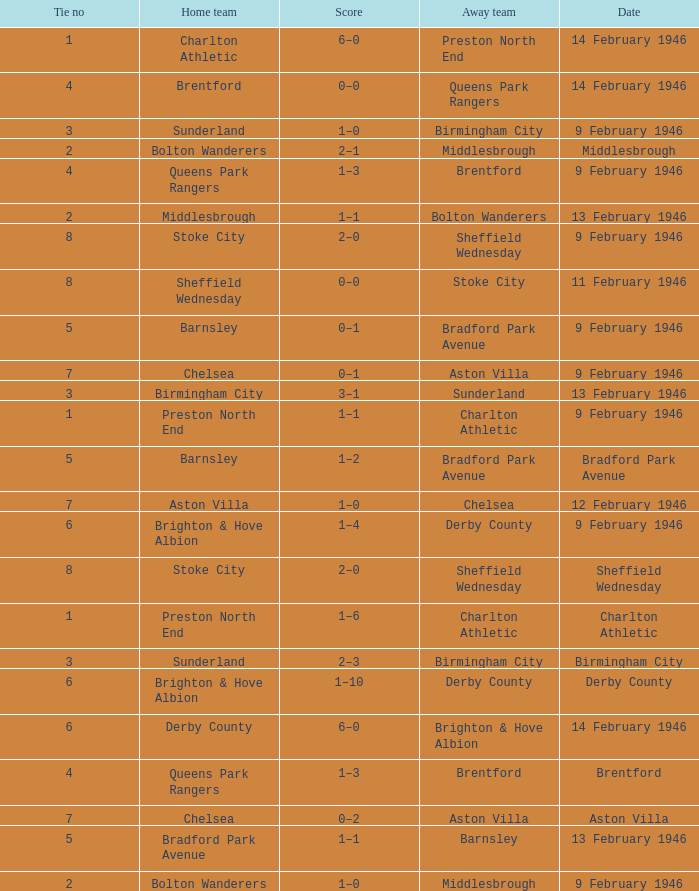What is the average Tie no when the date is Birmingham City? 3.0. 